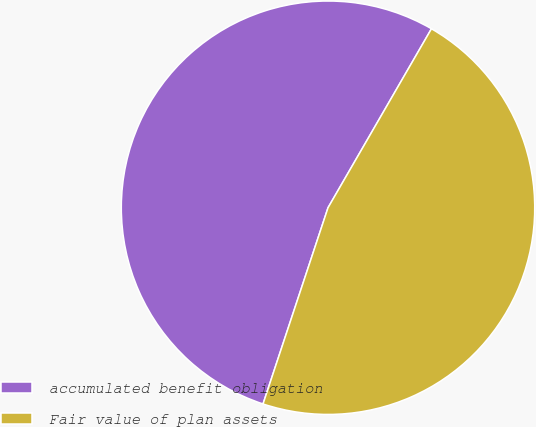<chart> <loc_0><loc_0><loc_500><loc_500><pie_chart><fcel>accumulated benefit obligation<fcel>Fair value of plan assets<nl><fcel>53.25%<fcel>46.75%<nl></chart> 